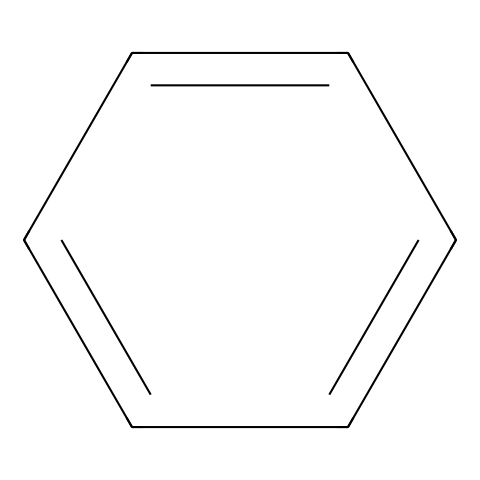What is the molecular formula of this compound? Benzene consists of six carbon atoms and six hydrogen atoms, which can be represented as C6H6.
Answer: C6H6 How many conjugated double bonds are present in this molecule? The structure of benzene shows that there are three double bonds arranged conjugatively in a cyclic manner, allowing for resonance stabilization. However, these double bonds are often depicted as an alternating single and double bond structure.
Answer: 3 What type of hybridization do the carbon atoms in this compound undergo? Each carbon atom in benzene is sp2 hybridized, which involves the mixing of one s orbital and two p orbitals to form three sp2 hybrid orbitals in a plane, leading to the planar structure of benzene.
Answer: sp2 What characteristic aroma does this compound have? Benzene is known for its sweet, aromatic scent, which makes it distinct among organic compounds. This smell is due to its aromatic nature.
Answer: sweet Explain the stability of benzene compared to alkenes. Benzene exhibits aromatic stability due to its cyclic structure and the delocalization of electrons across all six carbon atoms, which lowers its overall energy compared to alkenes that do not have this resonance stabilization. This results in benzene being less reactive in addition reactions typical of alkenes.
Answer: greater stability Is benzene classified as a saturated or unsaturated compound? Although benzene contains double bonds, it is classified as unsaturated due to the presence of conjugated pi electrons that allow for resonance; however, it does not react like typical unsaturated compounds, such as alkenes.
Answer: unsaturated 